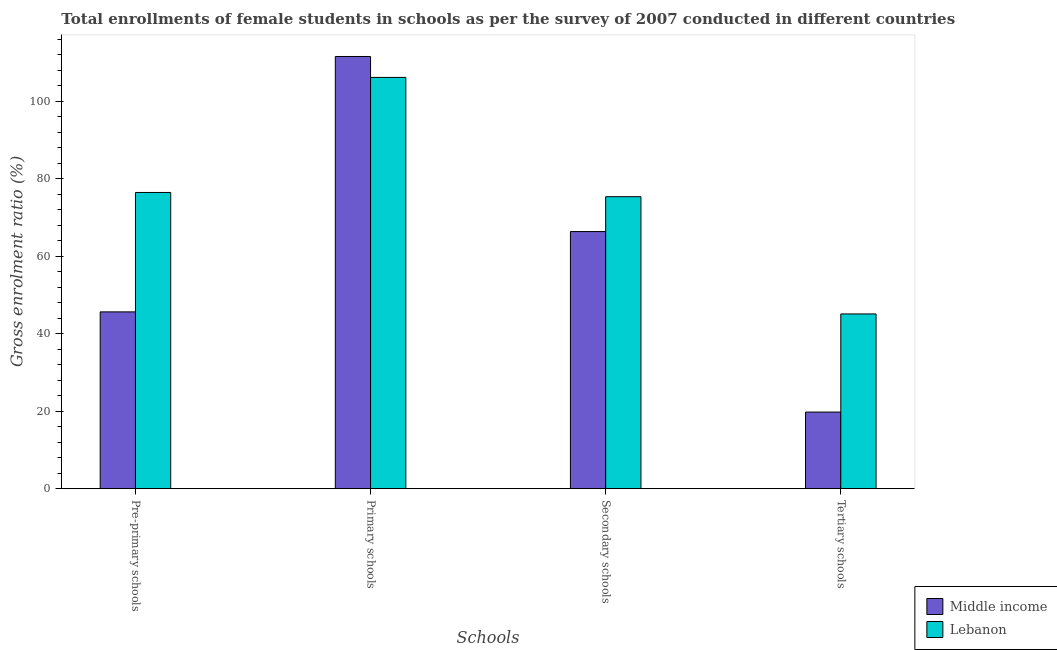How many different coloured bars are there?
Your answer should be compact. 2. How many groups of bars are there?
Make the answer very short. 4. Are the number of bars on each tick of the X-axis equal?
Give a very brief answer. Yes. How many bars are there on the 3rd tick from the right?
Keep it short and to the point. 2. What is the label of the 3rd group of bars from the left?
Provide a succinct answer. Secondary schools. What is the gross enrolment ratio(female) in secondary schools in Middle income?
Offer a very short reply. 66.36. Across all countries, what is the maximum gross enrolment ratio(female) in tertiary schools?
Keep it short and to the point. 45.1. Across all countries, what is the minimum gross enrolment ratio(female) in pre-primary schools?
Ensure brevity in your answer.  45.63. In which country was the gross enrolment ratio(female) in secondary schools maximum?
Keep it short and to the point. Lebanon. In which country was the gross enrolment ratio(female) in pre-primary schools minimum?
Provide a succinct answer. Middle income. What is the total gross enrolment ratio(female) in secondary schools in the graph?
Your answer should be very brief. 141.72. What is the difference between the gross enrolment ratio(female) in pre-primary schools in Lebanon and that in Middle income?
Your answer should be very brief. 30.82. What is the difference between the gross enrolment ratio(female) in primary schools in Middle income and the gross enrolment ratio(female) in pre-primary schools in Lebanon?
Make the answer very short. 35.09. What is the average gross enrolment ratio(female) in primary schools per country?
Provide a succinct answer. 108.84. What is the difference between the gross enrolment ratio(female) in secondary schools and gross enrolment ratio(female) in primary schools in Middle income?
Offer a very short reply. -45.18. In how many countries, is the gross enrolment ratio(female) in pre-primary schools greater than 96 %?
Keep it short and to the point. 0. What is the ratio of the gross enrolment ratio(female) in primary schools in Lebanon to that in Middle income?
Give a very brief answer. 0.95. What is the difference between the highest and the second highest gross enrolment ratio(female) in pre-primary schools?
Offer a very short reply. 30.82. What is the difference between the highest and the lowest gross enrolment ratio(female) in primary schools?
Give a very brief answer. 5.4. Is the sum of the gross enrolment ratio(female) in tertiary schools in Middle income and Lebanon greater than the maximum gross enrolment ratio(female) in pre-primary schools across all countries?
Make the answer very short. No. What does the 2nd bar from the left in Pre-primary schools represents?
Provide a short and direct response. Lebanon. What does the 1st bar from the right in Primary schools represents?
Offer a very short reply. Lebanon. How many countries are there in the graph?
Your answer should be very brief. 2. Where does the legend appear in the graph?
Offer a very short reply. Bottom right. How many legend labels are there?
Offer a very short reply. 2. How are the legend labels stacked?
Offer a very short reply. Vertical. What is the title of the graph?
Offer a very short reply. Total enrollments of female students in schools as per the survey of 2007 conducted in different countries. What is the label or title of the X-axis?
Your answer should be compact. Schools. What is the Gross enrolment ratio (%) in Middle income in Pre-primary schools?
Make the answer very short. 45.63. What is the Gross enrolment ratio (%) of Lebanon in Pre-primary schools?
Make the answer very short. 76.45. What is the Gross enrolment ratio (%) in Middle income in Primary schools?
Keep it short and to the point. 111.54. What is the Gross enrolment ratio (%) of Lebanon in Primary schools?
Your response must be concise. 106.14. What is the Gross enrolment ratio (%) in Middle income in Secondary schools?
Provide a short and direct response. 66.36. What is the Gross enrolment ratio (%) of Lebanon in Secondary schools?
Ensure brevity in your answer.  75.36. What is the Gross enrolment ratio (%) in Middle income in Tertiary schools?
Your answer should be very brief. 19.77. What is the Gross enrolment ratio (%) of Lebanon in Tertiary schools?
Your answer should be compact. 45.1. Across all Schools, what is the maximum Gross enrolment ratio (%) in Middle income?
Your answer should be compact. 111.54. Across all Schools, what is the maximum Gross enrolment ratio (%) in Lebanon?
Your answer should be very brief. 106.14. Across all Schools, what is the minimum Gross enrolment ratio (%) in Middle income?
Offer a terse response. 19.77. Across all Schools, what is the minimum Gross enrolment ratio (%) of Lebanon?
Make the answer very short. 45.1. What is the total Gross enrolment ratio (%) of Middle income in the graph?
Your answer should be very brief. 243.29. What is the total Gross enrolment ratio (%) in Lebanon in the graph?
Keep it short and to the point. 303.04. What is the difference between the Gross enrolment ratio (%) in Middle income in Pre-primary schools and that in Primary schools?
Make the answer very short. -65.91. What is the difference between the Gross enrolment ratio (%) in Lebanon in Pre-primary schools and that in Primary schools?
Provide a succinct answer. -29.69. What is the difference between the Gross enrolment ratio (%) of Middle income in Pre-primary schools and that in Secondary schools?
Your answer should be very brief. -20.73. What is the difference between the Gross enrolment ratio (%) in Lebanon in Pre-primary schools and that in Secondary schools?
Keep it short and to the point. 1.09. What is the difference between the Gross enrolment ratio (%) of Middle income in Pre-primary schools and that in Tertiary schools?
Keep it short and to the point. 25.86. What is the difference between the Gross enrolment ratio (%) in Lebanon in Pre-primary schools and that in Tertiary schools?
Give a very brief answer. 31.35. What is the difference between the Gross enrolment ratio (%) of Middle income in Primary schools and that in Secondary schools?
Your answer should be very brief. 45.18. What is the difference between the Gross enrolment ratio (%) in Lebanon in Primary schools and that in Secondary schools?
Offer a very short reply. 30.78. What is the difference between the Gross enrolment ratio (%) in Middle income in Primary schools and that in Tertiary schools?
Offer a very short reply. 91.77. What is the difference between the Gross enrolment ratio (%) in Lebanon in Primary schools and that in Tertiary schools?
Offer a very short reply. 61.04. What is the difference between the Gross enrolment ratio (%) in Middle income in Secondary schools and that in Tertiary schools?
Keep it short and to the point. 46.59. What is the difference between the Gross enrolment ratio (%) of Lebanon in Secondary schools and that in Tertiary schools?
Keep it short and to the point. 30.26. What is the difference between the Gross enrolment ratio (%) in Middle income in Pre-primary schools and the Gross enrolment ratio (%) in Lebanon in Primary schools?
Your response must be concise. -60.51. What is the difference between the Gross enrolment ratio (%) in Middle income in Pre-primary schools and the Gross enrolment ratio (%) in Lebanon in Secondary schools?
Your answer should be compact. -29.73. What is the difference between the Gross enrolment ratio (%) of Middle income in Pre-primary schools and the Gross enrolment ratio (%) of Lebanon in Tertiary schools?
Offer a terse response. 0.53. What is the difference between the Gross enrolment ratio (%) in Middle income in Primary schools and the Gross enrolment ratio (%) in Lebanon in Secondary schools?
Provide a short and direct response. 36.18. What is the difference between the Gross enrolment ratio (%) in Middle income in Primary schools and the Gross enrolment ratio (%) in Lebanon in Tertiary schools?
Make the answer very short. 66.44. What is the difference between the Gross enrolment ratio (%) of Middle income in Secondary schools and the Gross enrolment ratio (%) of Lebanon in Tertiary schools?
Your response must be concise. 21.26. What is the average Gross enrolment ratio (%) of Middle income per Schools?
Give a very brief answer. 60.82. What is the average Gross enrolment ratio (%) in Lebanon per Schools?
Give a very brief answer. 75.76. What is the difference between the Gross enrolment ratio (%) of Middle income and Gross enrolment ratio (%) of Lebanon in Pre-primary schools?
Make the answer very short. -30.82. What is the difference between the Gross enrolment ratio (%) of Middle income and Gross enrolment ratio (%) of Lebanon in Primary schools?
Your response must be concise. 5.4. What is the difference between the Gross enrolment ratio (%) of Middle income and Gross enrolment ratio (%) of Lebanon in Secondary schools?
Offer a terse response. -9. What is the difference between the Gross enrolment ratio (%) in Middle income and Gross enrolment ratio (%) in Lebanon in Tertiary schools?
Keep it short and to the point. -25.32. What is the ratio of the Gross enrolment ratio (%) in Middle income in Pre-primary schools to that in Primary schools?
Provide a short and direct response. 0.41. What is the ratio of the Gross enrolment ratio (%) in Lebanon in Pre-primary schools to that in Primary schools?
Offer a very short reply. 0.72. What is the ratio of the Gross enrolment ratio (%) of Middle income in Pre-primary schools to that in Secondary schools?
Your response must be concise. 0.69. What is the ratio of the Gross enrolment ratio (%) in Lebanon in Pre-primary schools to that in Secondary schools?
Provide a short and direct response. 1.01. What is the ratio of the Gross enrolment ratio (%) in Middle income in Pre-primary schools to that in Tertiary schools?
Provide a succinct answer. 2.31. What is the ratio of the Gross enrolment ratio (%) in Lebanon in Pre-primary schools to that in Tertiary schools?
Offer a terse response. 1.7. What is the ratio of the Gross enrolment ratio (%) of Middle income in Primary schools to that in Secondary schools?
Make the answer very short. 1.68. What is the ratio of the Gross enrolment ratio (%) in Lebanon in Primary schools to that in Secondary schools?
Offer a terse response. 1.41. What is the ratio of the Gross enrolment ratio (%) in Middle income in Primary schools to that in Tertiary schools?
Offer a very short reply. 5.64. What is the ratio of the Gross enrolment ratio (%) of Lebanon in Primary schools to that in Tertiary schools?
Your answer should be very brief. 2.35. What is the ratio of the Gross enrolment ratio (%) in Middle income in Secondary schools to that in Tertiary schools?
Make the answer very short. 3.36. What is the ratio of the Gross enrolment ratio (%) in Lebanon in Secondary schools to that in Tertiary schools?
Offer a terse response. 1.67. What is the difference between the highest and the second highest Gross enrolment ratio (%) in Middle income?
Provide a short and direct response. 45.18. What is the difference between the highest and the second highest Gross enrolment ratio (%) in Lebanon?
Make the answer very short. 29.69. What is the difference between the highest and the lowest Gross enrolment ratio (%) of Middle income?
Provide a short and direct response. 91.77. What is the difference between the highest and the lowest Gross enrolment ratio (%) of Lebanon?
Provide a succinct answer. 61.04. 